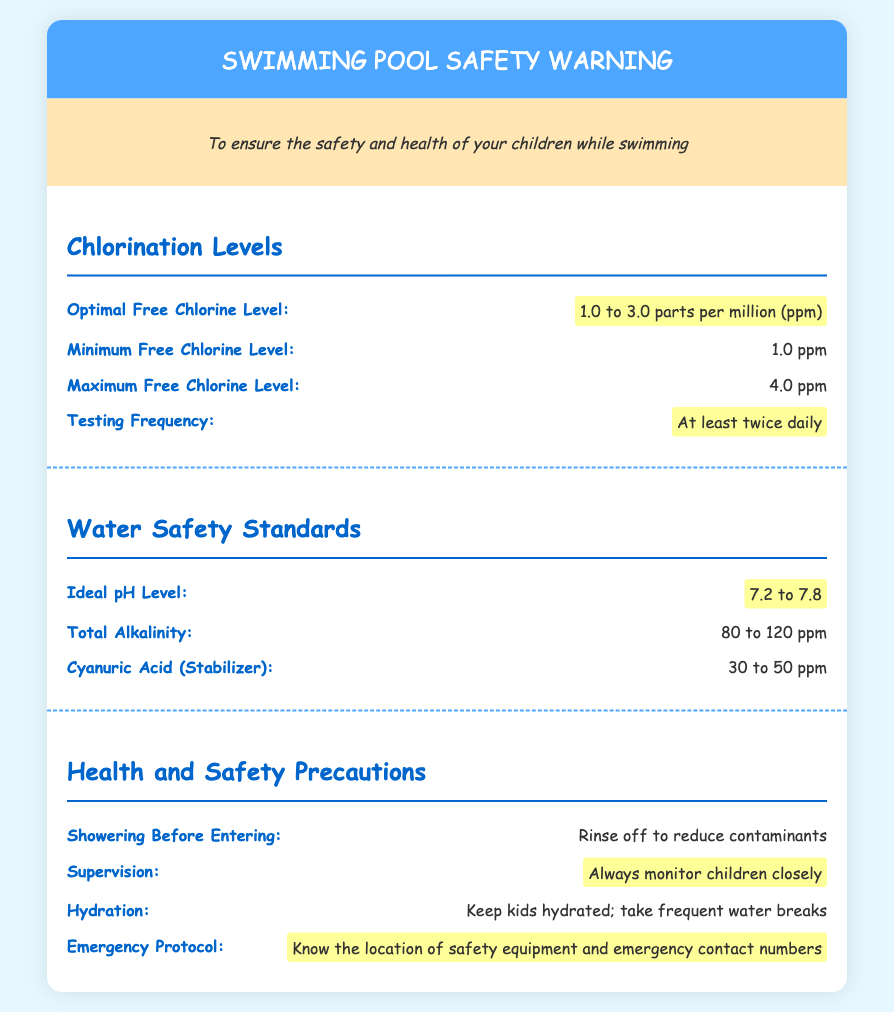What is the optimal free chlorine level? The optimal free chlorine level is specified in the document as being between 1.0 and 3.0 parts per million (ppm).
Answer: 1.0 to 3.0 ppm What is the ideal pH level for the pool water? The document provides the ideal pH level, which is necessary for safe swimming, stated as between 7.2 and 7.8.
Answer: 7.2 to 7.8 How often should chlorination levels be tested? The document specifies the testing frequency for chlorination levels should be at least twice a day to ensure water safety.
Answer: At least twice daily What is the minimum free chlorine level? The minimum free chlorine level is outlined in the document as the lowest acceptable concentration for pool water safety.
Answer: 1.0 ppm What should you know regarding emergency protocols? The document emphasizes knowing the location of safety equipment and emergency contact numbers as crucial for responding to incidents.
Answer: Know the location of safety equipment and emergency contact numbers Why is showering before entering the pool important? The document mentions rinsing off before entering reduces contaminants, emphasizing hygiene for pool safety.
Answer: Reduce contaminants What is the recommended total alkalinity level? The recommended total alkalinity level is stated in the document to help maintain pool water chemistry effectively.
Answer: 80 to 120 ppm How can parents ensure children stay hydrated? The document suggests keeping kids hydrated by encouraging frequent water breaks during pool activities.
Answer: Frequent water breaks What is crucial for supervising children in the pool? The document highlights that always monitoring children closely is crucial for their safety when swimming.
Answer: Always monitor children closely 